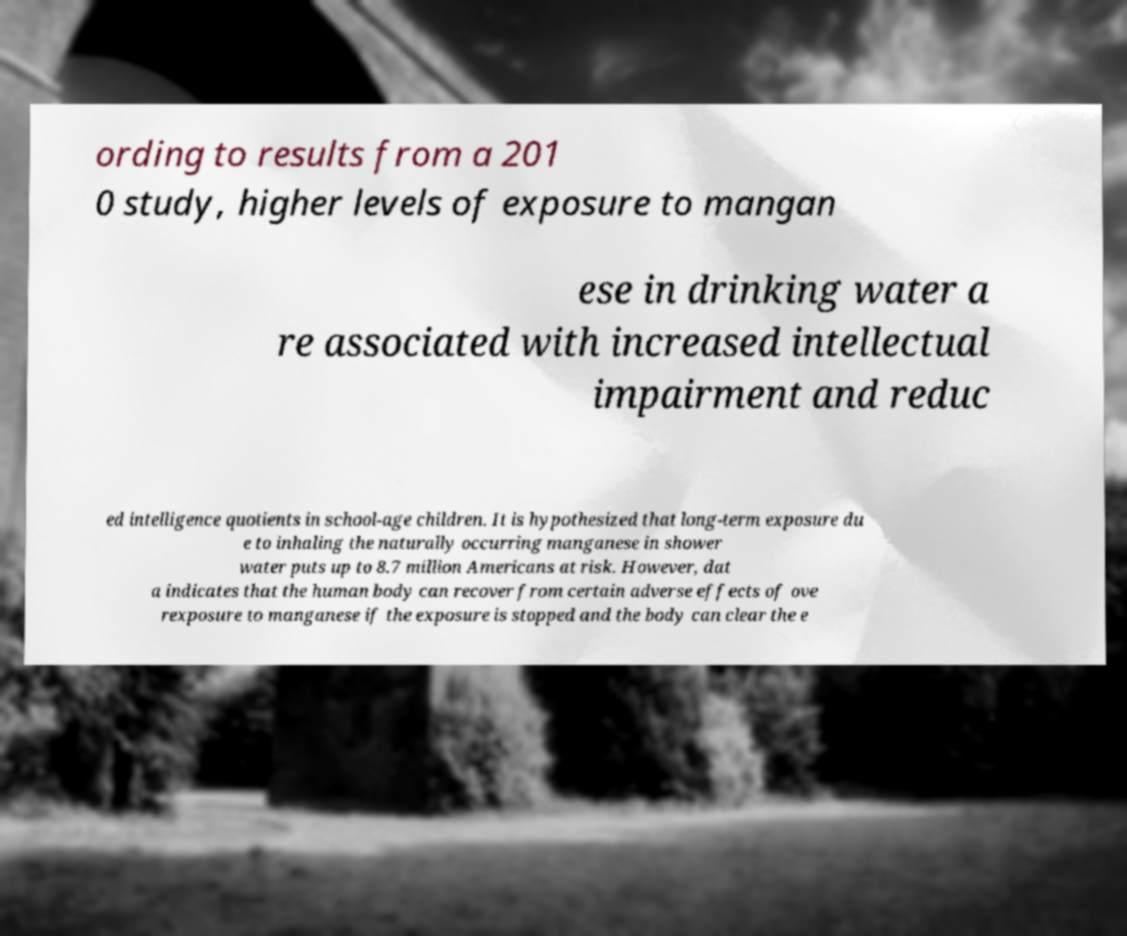I need the written content from this picture converted into text. Can you do that? ording to results from a 201 0 study, higher levels of exposure to mangan ese in drinking water a re associated with increased intellectual impairment and reduc ed intelligence quotients in school-age children. It is hypothesized that long-term exposure du e to inhaling the naturally occurring manganese in shower water puts up to 8.7 million Americans at risk. However, dat a indicates that the human body can recover from certain adverse effects of ove rexposure to manganese if the exposure is stopped and the body can clear the e 